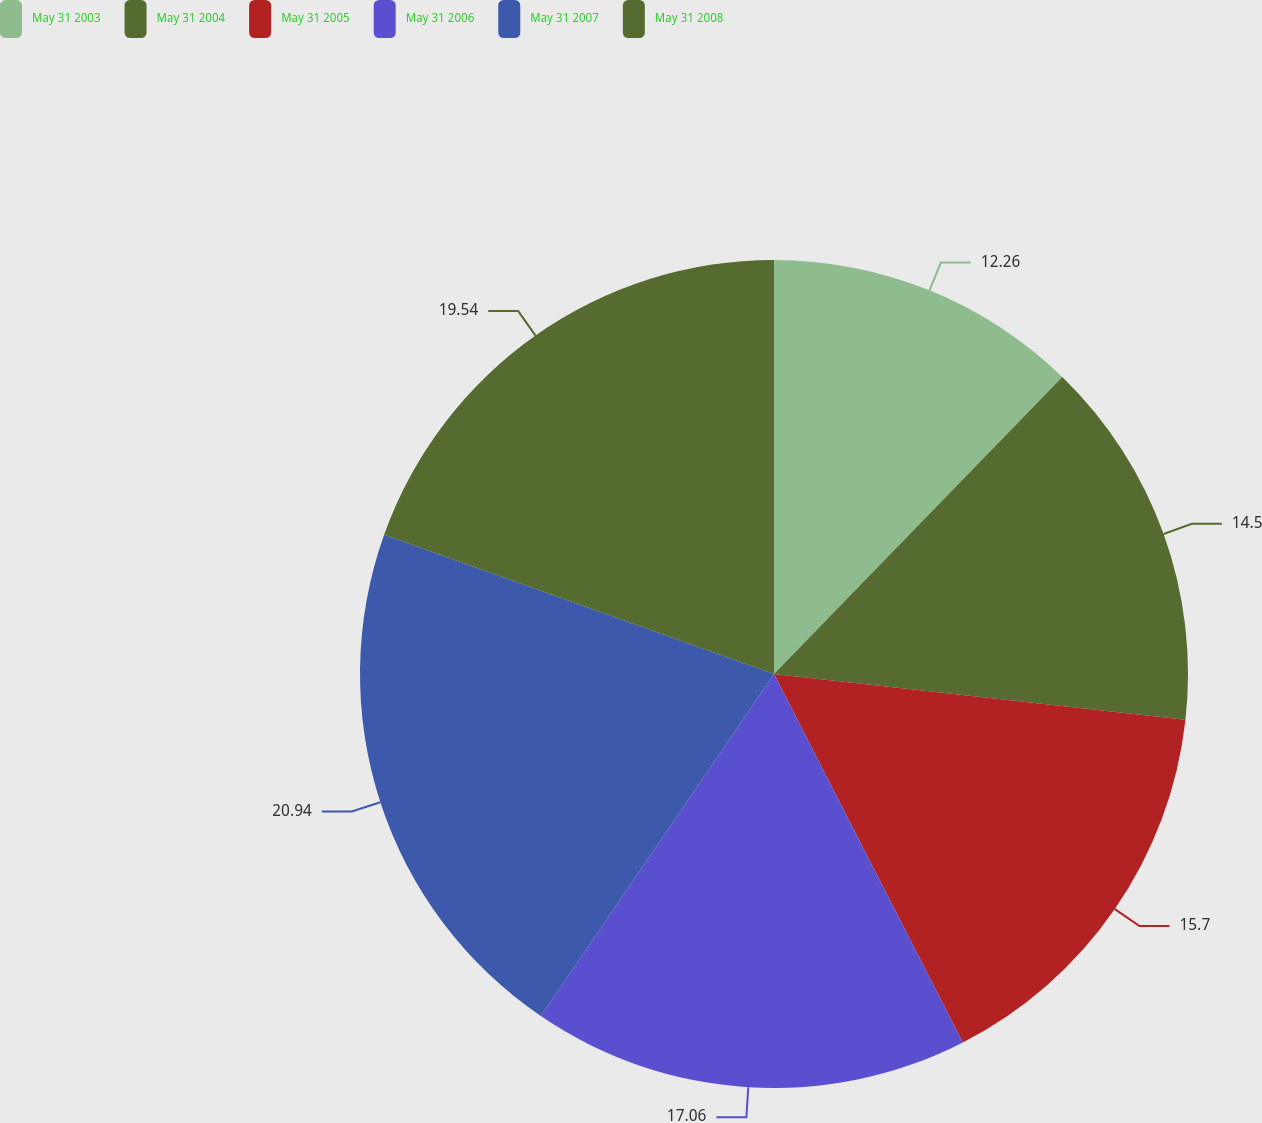Convert chart to OTSL. <chart><loc_0><loc_0><loc_500><loc_500><pie_chart><fcel>May 31 2003<fcel>May 31 2004<fcel>May 31 2005<fcel>May 31 2006<fcel>May 31 2007<fcel>May 31 2008<nl><fcel>12.26%<fcel>14.5%<fcel>15.7%<fcel>17.06%<fcel>20.94%<fcel>19.54%<nl></chart> 